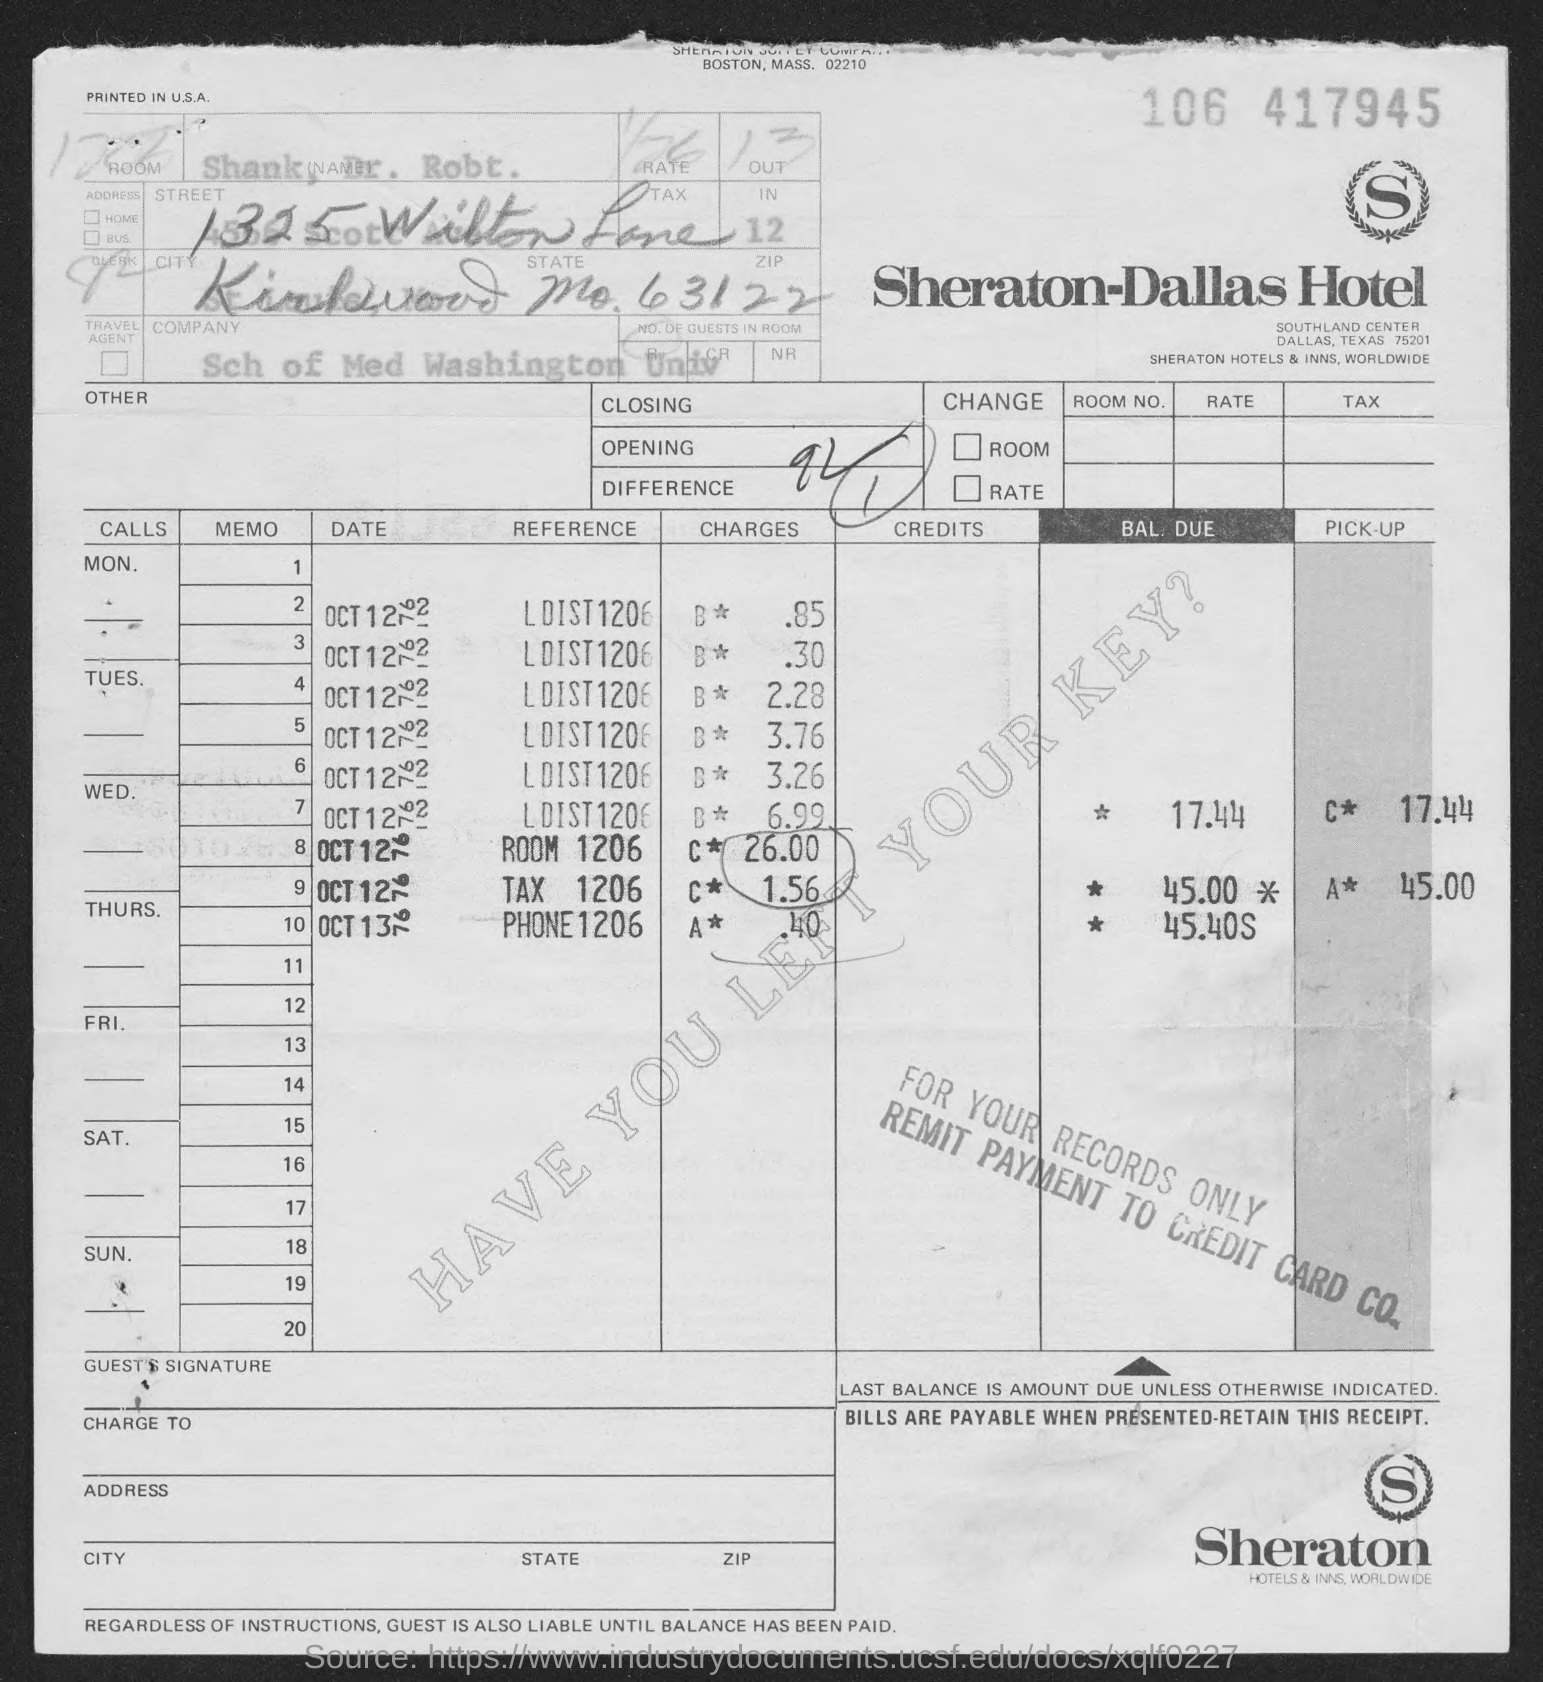Which hotel bill is provided?
Your answer should be very brief. SHERATON HOTELS & INNS, WORLDWIDE. 